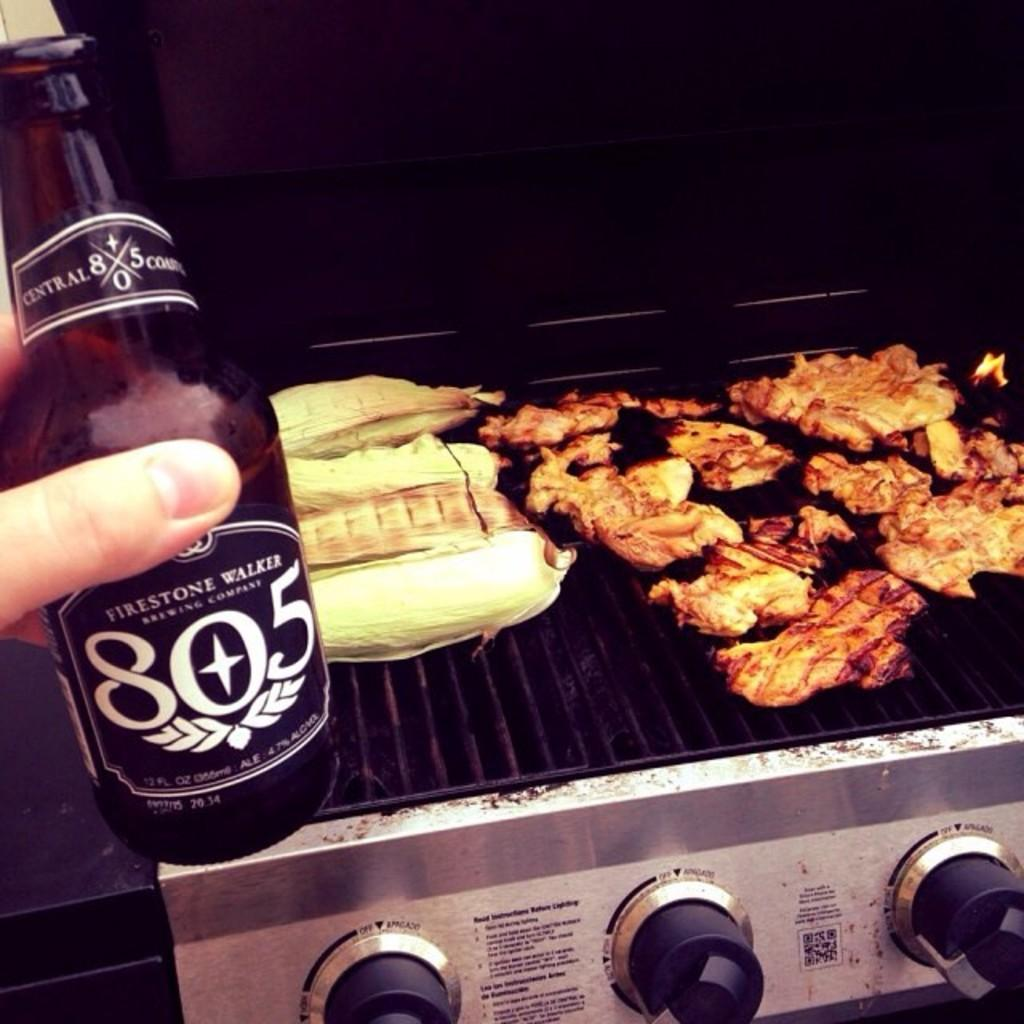Provide a one-sentence caption for the provided image. Firestone Walker 805 beer will go with the food on the grill. 